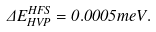<formula> <loc_0><loc_0><loc_500><loc_500>\Delta E _ { H V P } ^ { H F S } = 0 . 0 0 0 5 m e V .</formula> 